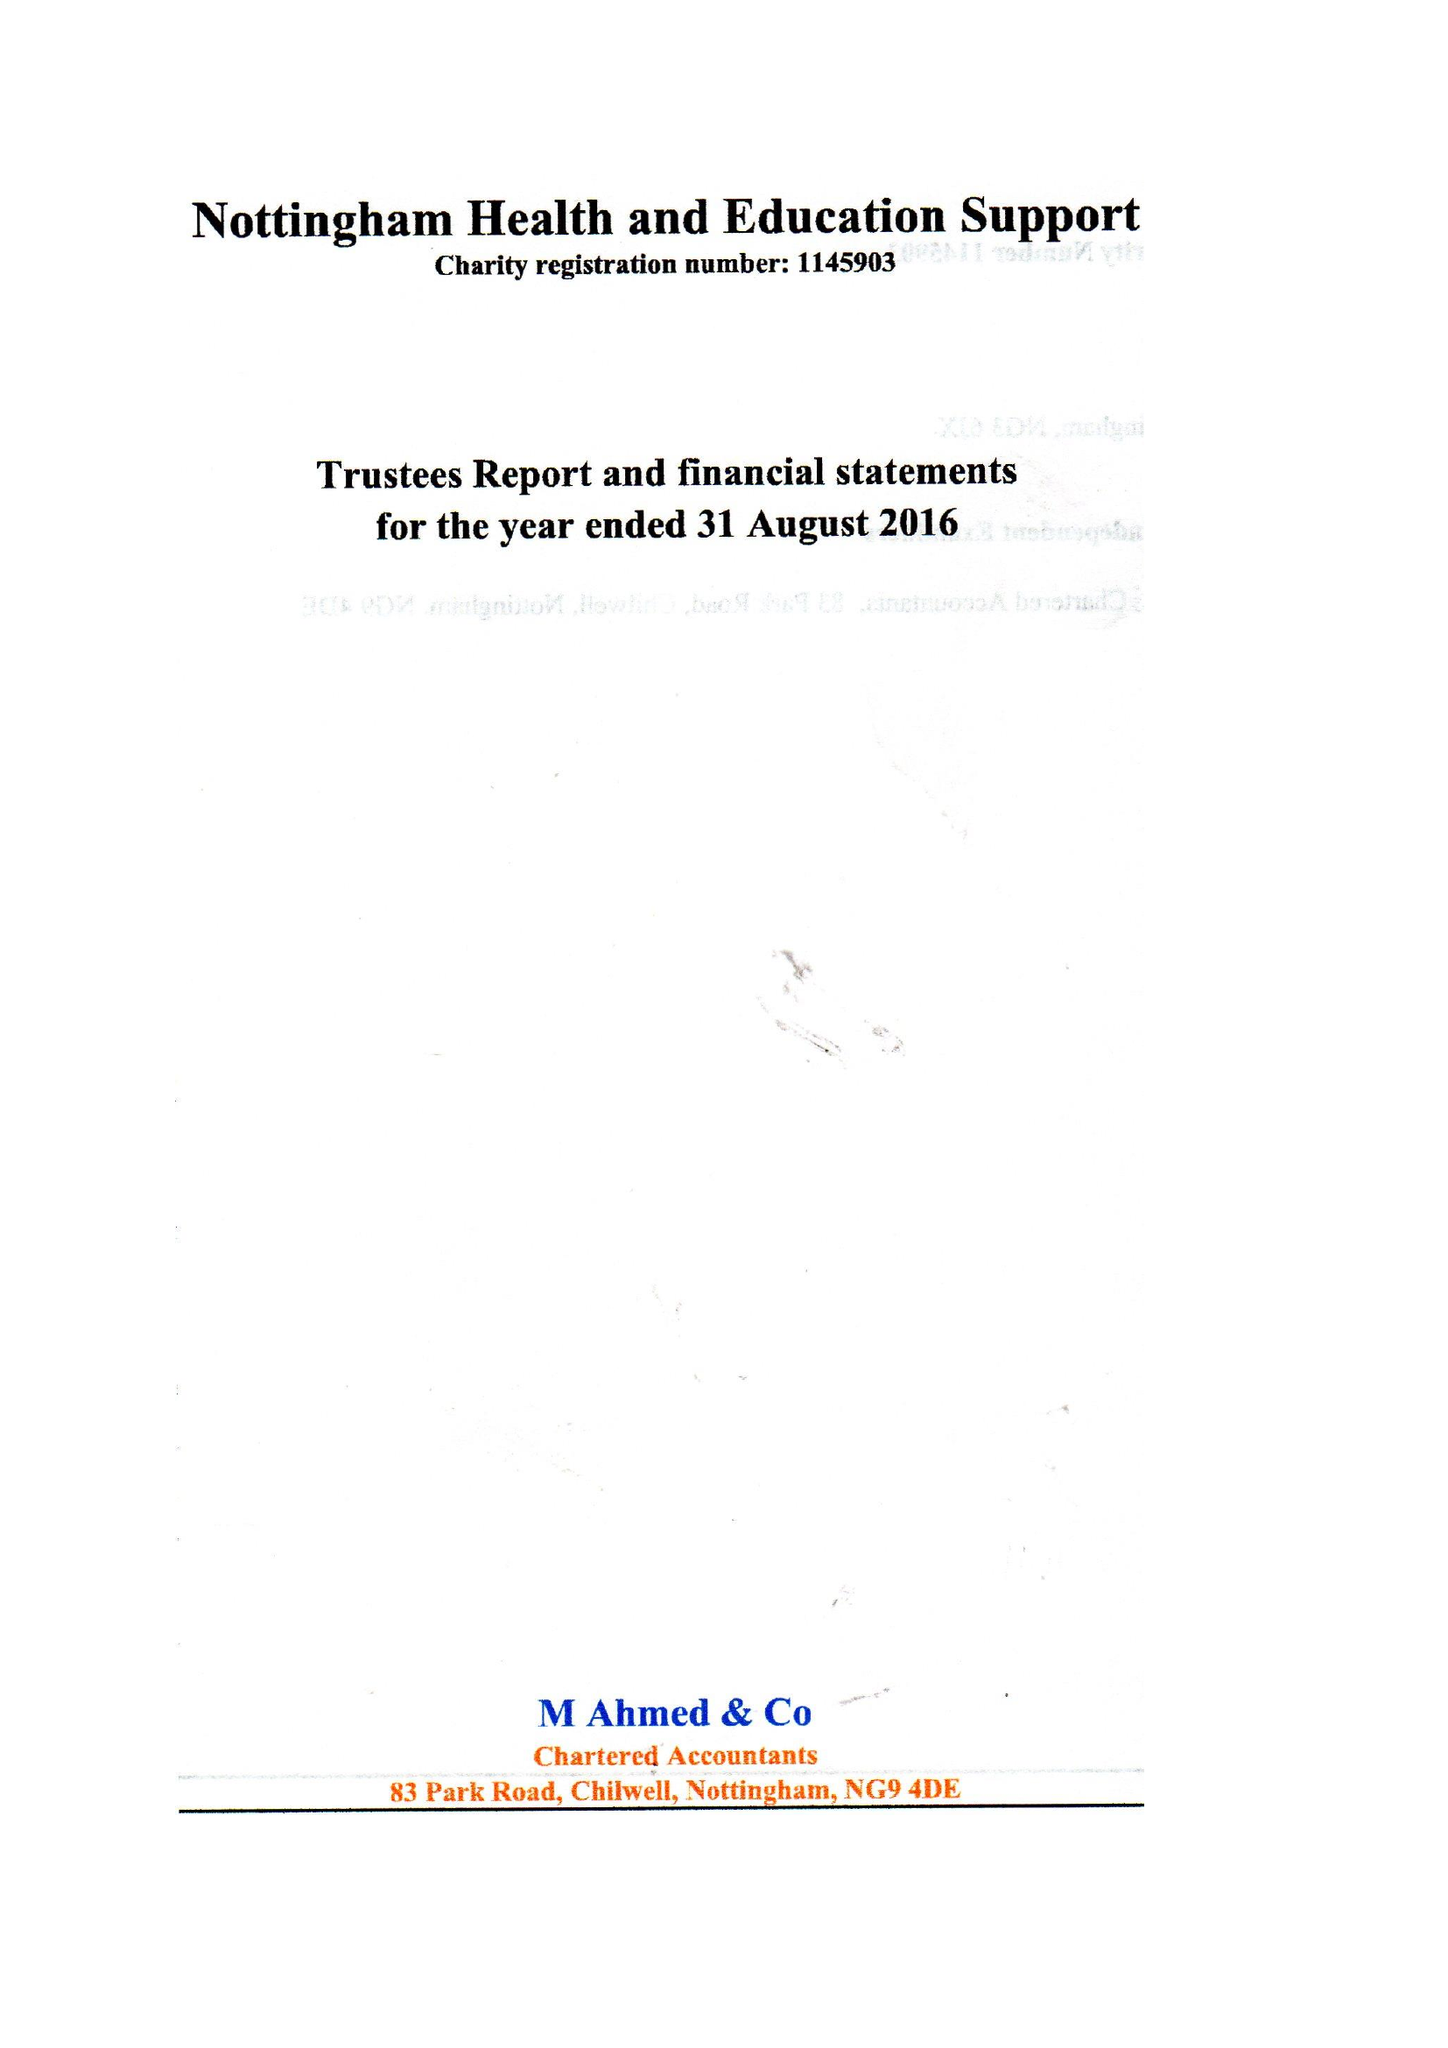What is the value for the report_date?
Answer the question using a single word or phrase. 2016-08-31 